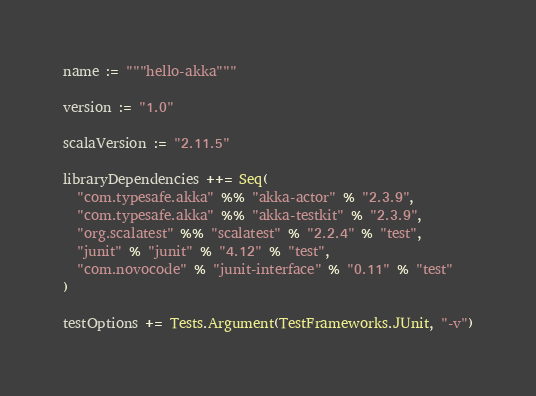<code> <loc_0><loc_0><loc_500><loc_500><_Scala_>name := """hello-akka"""

version := "1.0"

scalaVersion := "2.11.5"

libraryDependencies ++= Seq(
  "com.typesafe.akka" %% "akka-actor" % "2.3.9",
  "com.typesafe.akka" %% "akka-testkit" % "2.3.9",
  "org.scalatest" %% "scalatest" % "2.2.4" % "test",
  "junit" % "junit" % "4.12" % "test",
  "com.novocode" % "junit-interface" % "0.11" % "test"
)

testOptions += Tests.Argument(TestFrameworks.JUnit, "-v")
</code> 